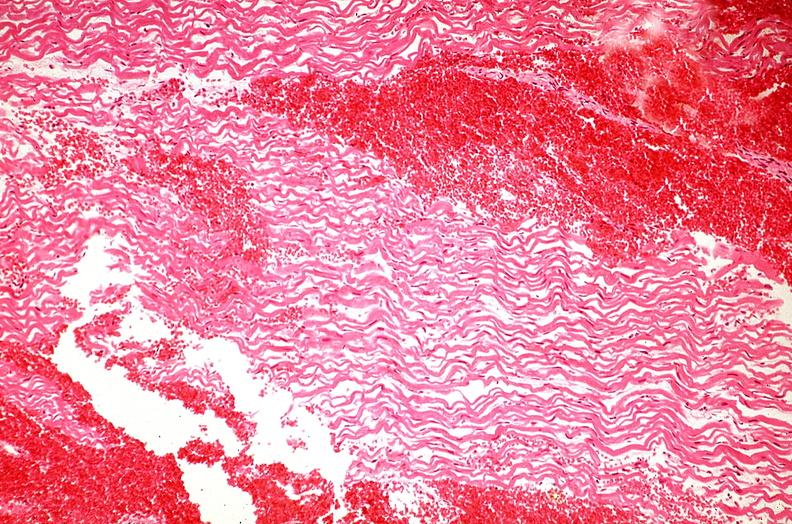what is present?
Answer the question using a single word or phrase. Cardiovascular 